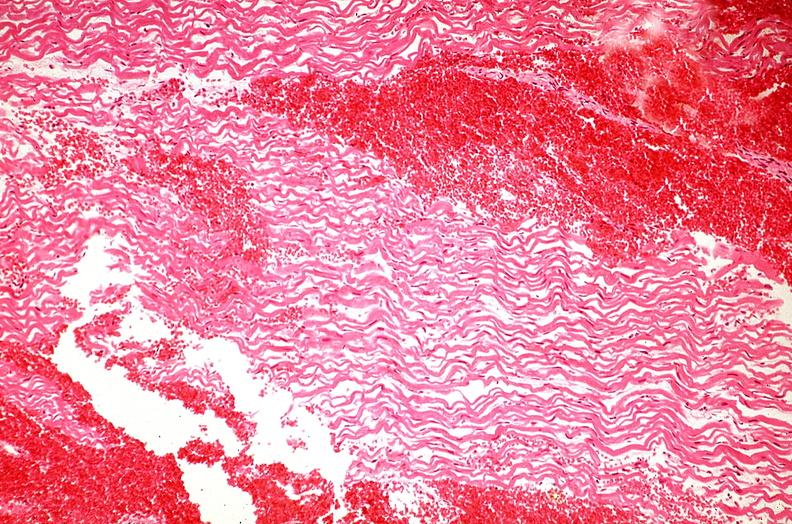what is present?
Answer the question using a single word or phrase. Cardiovascular 